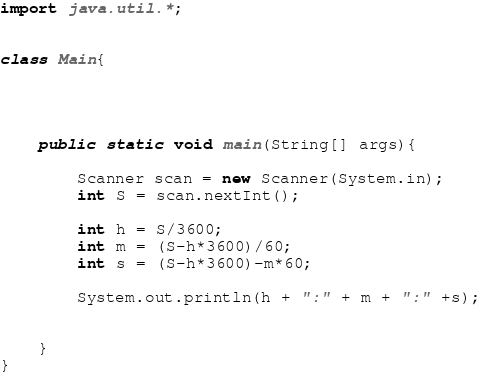Convert code to text. <code><loc_0><loc_0><loc_500><loc_500><_Java_>import java.util.*;


class Main{
	
	
	
	
	public static void main(String[] args){
		
		Scanner scan = new Scanner(System.in);
		int S = scan.nextInt();
		
		int h = S/3600;
		int m = (S-h*3600)/60;
		int s = (S-h*3600)-m*60;
		
		System.out.println(h + ":" + m + ":" +s);

		
	}
}</code> 